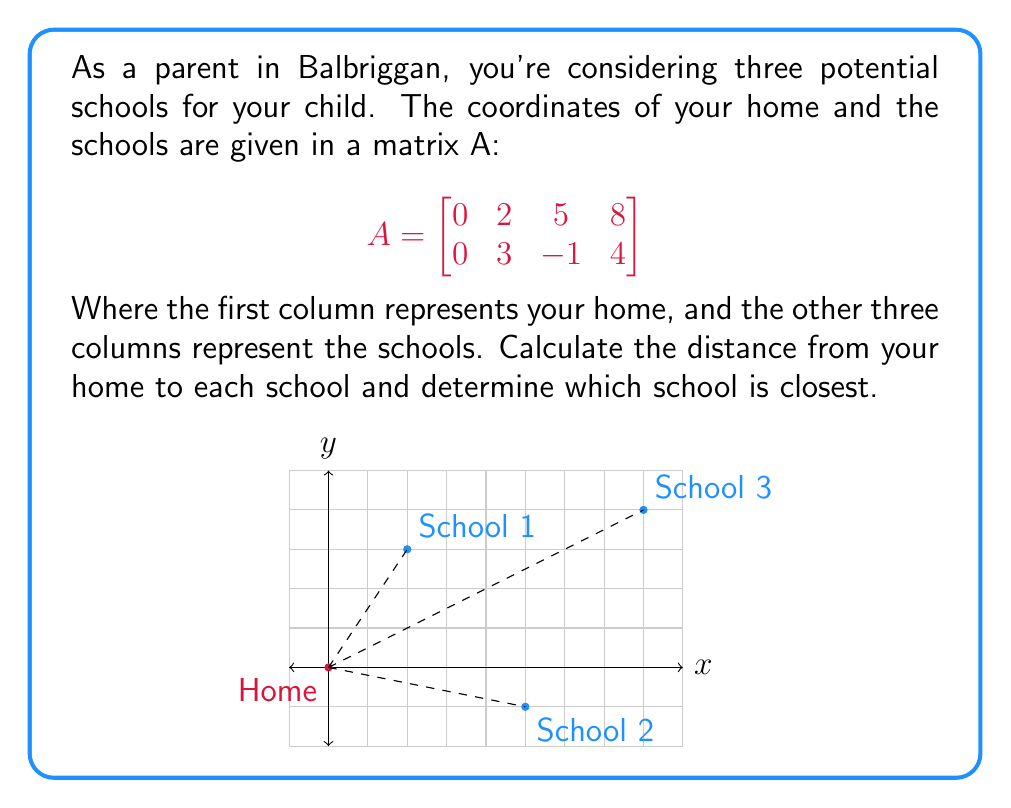Show me your answer to this math problem. Let's approach this step-by-step:

1) The distance between two points $(x_1, y_1)$ and $(x_2, y_2)$ is given by the formula:

   $$d = \sqrt{(x_2-x_1)^2 + (y_2-y_1)^2}$$

2) For each school, we need to calculate this distance from home (0,0):

   School 1 (2,3): 
   $$d_1 = \sqrt{(2-0)^2 + (3-0)^2} = \sqrt{4 + 9} = \sqrt{13}$$

   School 2 (5,-1):
   $$d_2 = \sqrt{(5-0)^2 + (-1-0)^2} = \sqrt{25 + 1} = \sqrt{26}$$

   School 3 (8,4):
   $$d_3 = \sqrt{(8-0)^2 + (4-0)^2} = \sqrt{64 + 16} = \sqrt{80} = 4\sqrt{5}$$

3) Now, let's compare these distances:
   $\sqrt{13} \approx 3.61$
   $\sqrt{26} \approx 5.10$
   $4\sqrt{5} \approx 8.94$

Therefore, School 1 is the closest to your home.
Answer: School 1 at (2,3) is closest, distance = $\sqrt{13}$ units. 